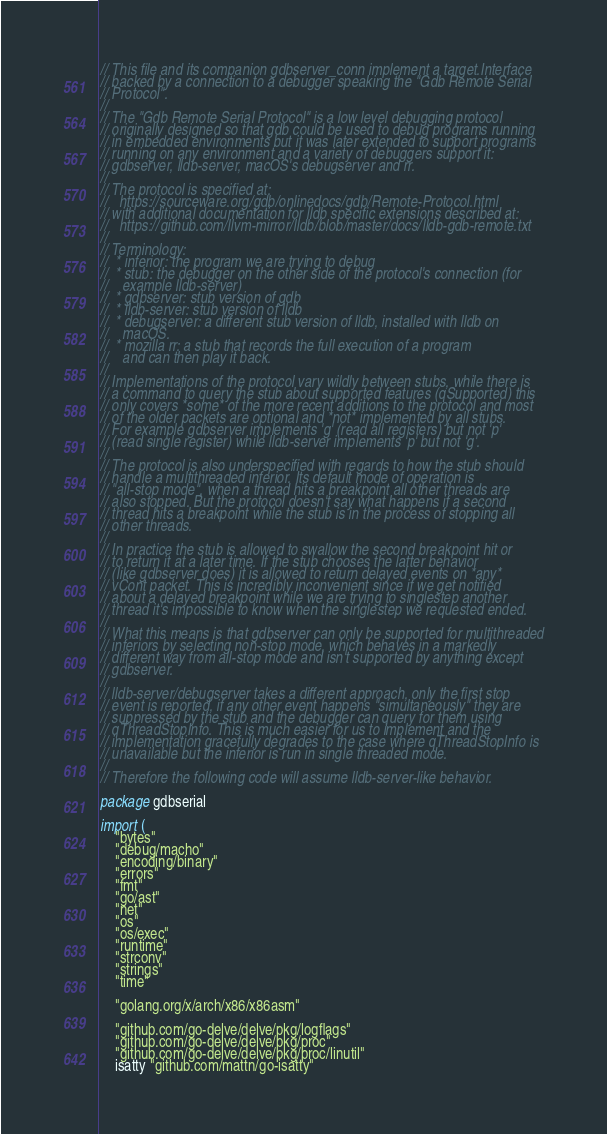Convert code to text. <code><loc_0><loc_0><loc_500><loc_500><_Go_>// This file and its companion gdbserver_conn implement a target.Interface
// backed by a connection to a debugger speaking the "Gdb Remote Serial
// Protocol".
//
// The "Gdb Remote Serial Protocol" is a low level debugging protocol
// originally designed so that gdb could be used to debug programs running
// in embedded environments but it was later extended to support programs
// running on any environment and a variety of debuggers support it:
// gdbserver, lldb-server, macOS's debugserver and rr.
//
// The protocol is specified at:
//   https://sourceware.org/gdb/onlinedocs/gdb/Remote-Protocol.html
// with additional documentation for lldb specific extensions described at:
//   https://github.com/llvm-mirror/lldb/blob/master/docs/lldb-gdb-remote.txt
//
// Terminology:
//  * inferior: the program we are trying to debug
//  * stub: the debugger on the other side of the protocol's connection (for
//    example lldb-server)
//  * gdbserver: stub version of gdb
//  * lldb-server: stub version of lldb
//  * debugserver: a different stub version of lldb, installed with lldb on
//    macOS.
//  * mozilla rr: a stub that records the full execution of a program
//    and can then play it back.
//
// Implementations of the protocol vary wildly between stubs, while there is
// a command to query the stub about supported features (qSupported) this
// only covers *some* of the more recent additions to the protocol and most
// of the older packets are optional and *not* implemented by all stubs.
// For example gdbserver implements 'g' (read all registers) but not 'p'
// (read single register) while lldb-server implements 'p' but not 'g'.
//
// The protocol is also underspecified with regards to how the stub should
// handle a multithreaded inferior. Its default mode of operation is
// "all-stop mode", when a thread hits a breakpoint all other threads are
// also stopped. But the protocol doesn't say what happens if a second
// thread hits a breakpoint while the stub is in the process of stopping all
// other threads.
//
// In practice the stub is allowed to swallow the second breakpoint hit or
// to return it at a later time. If the stub chooses the latter behavior
// (like gdbserver does) it is allowed to return delayed events on *any*
// vCont packet. This is incredibly inconvenient since if we get notified
// about a delayed breakpoint while we are trying to singlestep another
// thread it's impossible to know when the singlestep we requested ended.
//
// What this means is that gdbserver can only be supported for multithreaded
// inferiors by selecting non-stop mode, which behaves in a markedly
// different way from all-stop mode and isn't supported by anything except
// gdbserver.
//
// lldb-server/debugserver takes a different approach, only the first stop
// event is reported, if any other event happens "simultaneously" they are
// suppressed by the stub and the debugger can query for them using
// qThreadStopInfo. This is much easier for us to implement and the
// implementation gracefully degrades to the case where qThreadStopInfo is
// unavailable but the inferior is run in single threaded mode.
//
// Therefore the following code will assume lldb-server-like behavior.

package gdbserial

import (
	"bytes"
	"debug/macho"
	"encoding/binary"
	"errors"
	"fmt"
	"go/ast"
	"net"
	"os"
	"os/exec"
	"runtime"
	"strconv"
	"strings"
	"time"

	"golang.org/x/arch/x86/x86asm"

	"github.com/go-delve/delve/pkg/logflags"
	"github.com/go-delve/delve/pkg/proc"
	"github.com/go-delve/delve/pkg/proc/linutil"
	isatty "github.com/mattn/go-isatty"</code> 